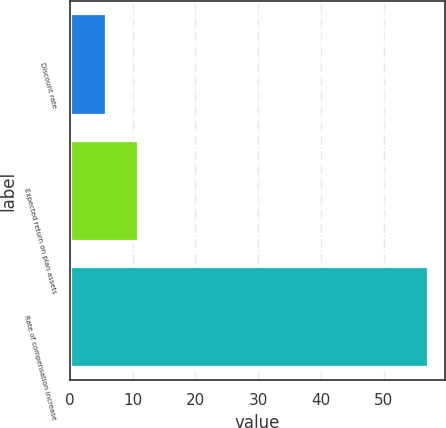Convert chart. <chart><loc_0><loc_0><loc_500><loc_500><bar_chart><fcel>Discount rate<fcel>Expected return on plan assets<fcel>Rate of compensation increase<nl><fcel>5.75<fcel>10.88<fcel>57<nl></chart> 